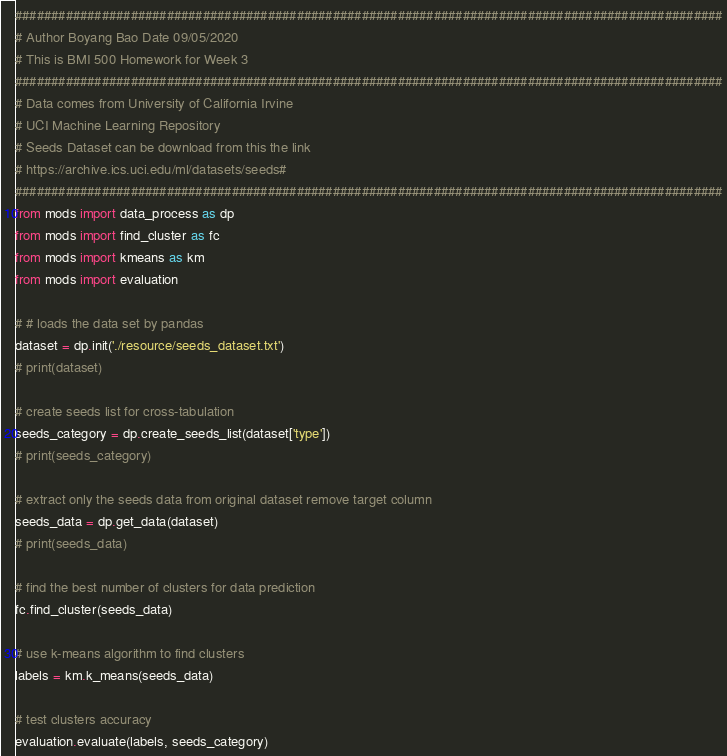Convert code to text. <code><loc_0><loc_0><loc_500><loc_500><_Python_>##################################################################################################
# Author Boyang Bao Date 09/05/2020
# This is BMI 500 Homework for Week 3
##################################################################################################
# Data comes from University of California Irvine
# UCI Machine Learning Repository
# Seeds Dataset can be download from this the link
# https://archive.ics.uci.edu/ml/datasets/seeds#
##################################################################################################
from mods import data_process as dp
from mods import find_cluster as fc
from mods import kmeans as km
from mods import evaluation

# # loads the data set by pandas
dataset = dp.init('./resource/seeds_dataset.txt')
# print(dataset)

# create seeds list for cross-tabulation
seeds_category = dp.create_seeds_list(dataset['type'])
# print(seeds_category)

# extract only the seeds data from original dataset remove target column
seeds_data = dp.get_data(dataset)
# print(seeds_data)

# find the best number of clusters for data prediction
fc.find_cluster(seeds_data)

# use k-means algorithm to find clusters
labels = km.k_means(seeds_data)

# test clusters accuracy
evaluation.evaluate(labels, seeds_category)
</code> 